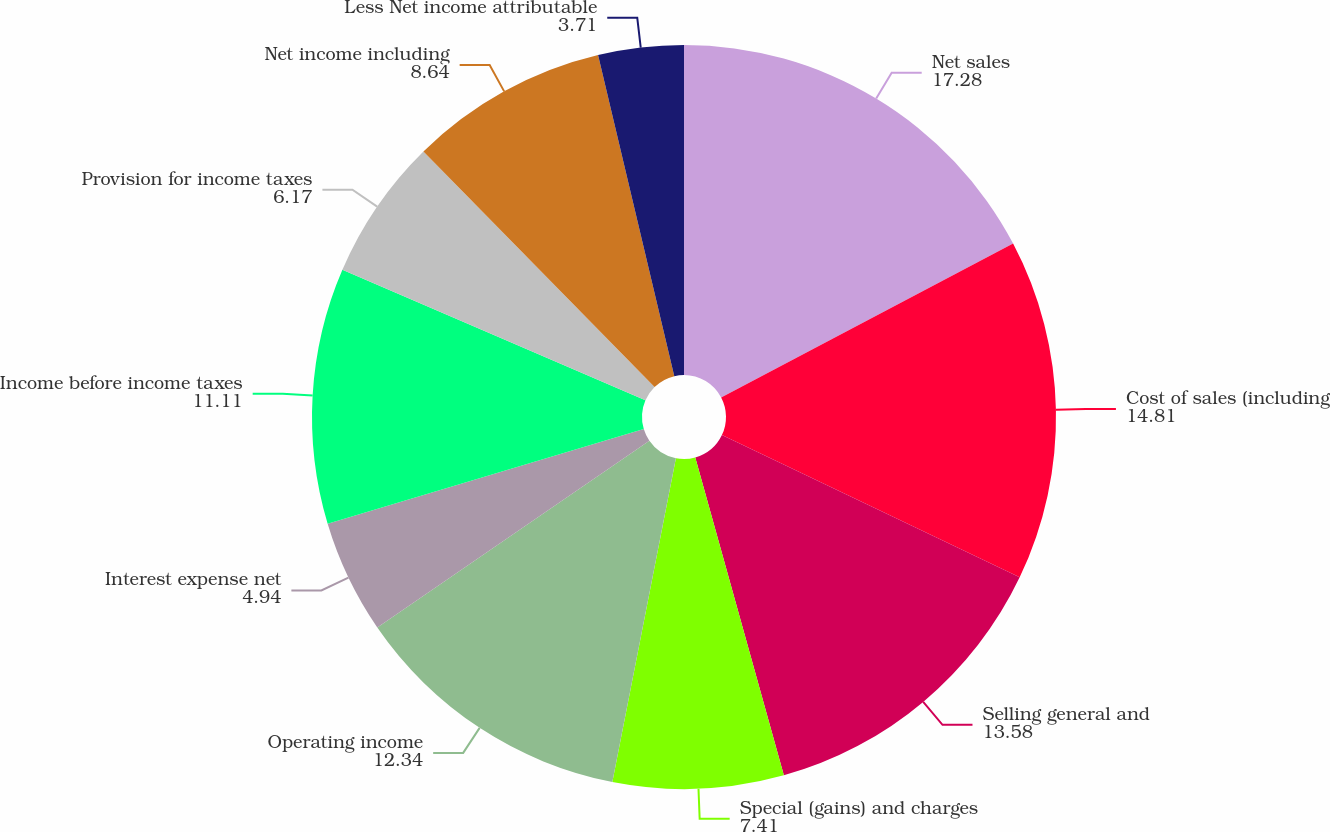<chart> <loc_0><loc_0><loc_500><loc_500><pie_chart><fcel>Net sales<fcel>Cost of sales (including<fcel>Selling general and<fcel>Special (gains) and charges<fcel>Operating income<fcel>Interest expense net<fcel>Income before income taxes<fcel>Provision for income taxes<fcel>Net income including<fcel>Less Net income attributable<nl><fcel>17.28%<fcel>14.81%<fcel>13.58%<fcel>7.41%<fcel>12.34%<fcel>4.94%<fcel>11.11%<fcel>6.17%<fcel>8.64%<fcel>3.71%<nl></chart> 